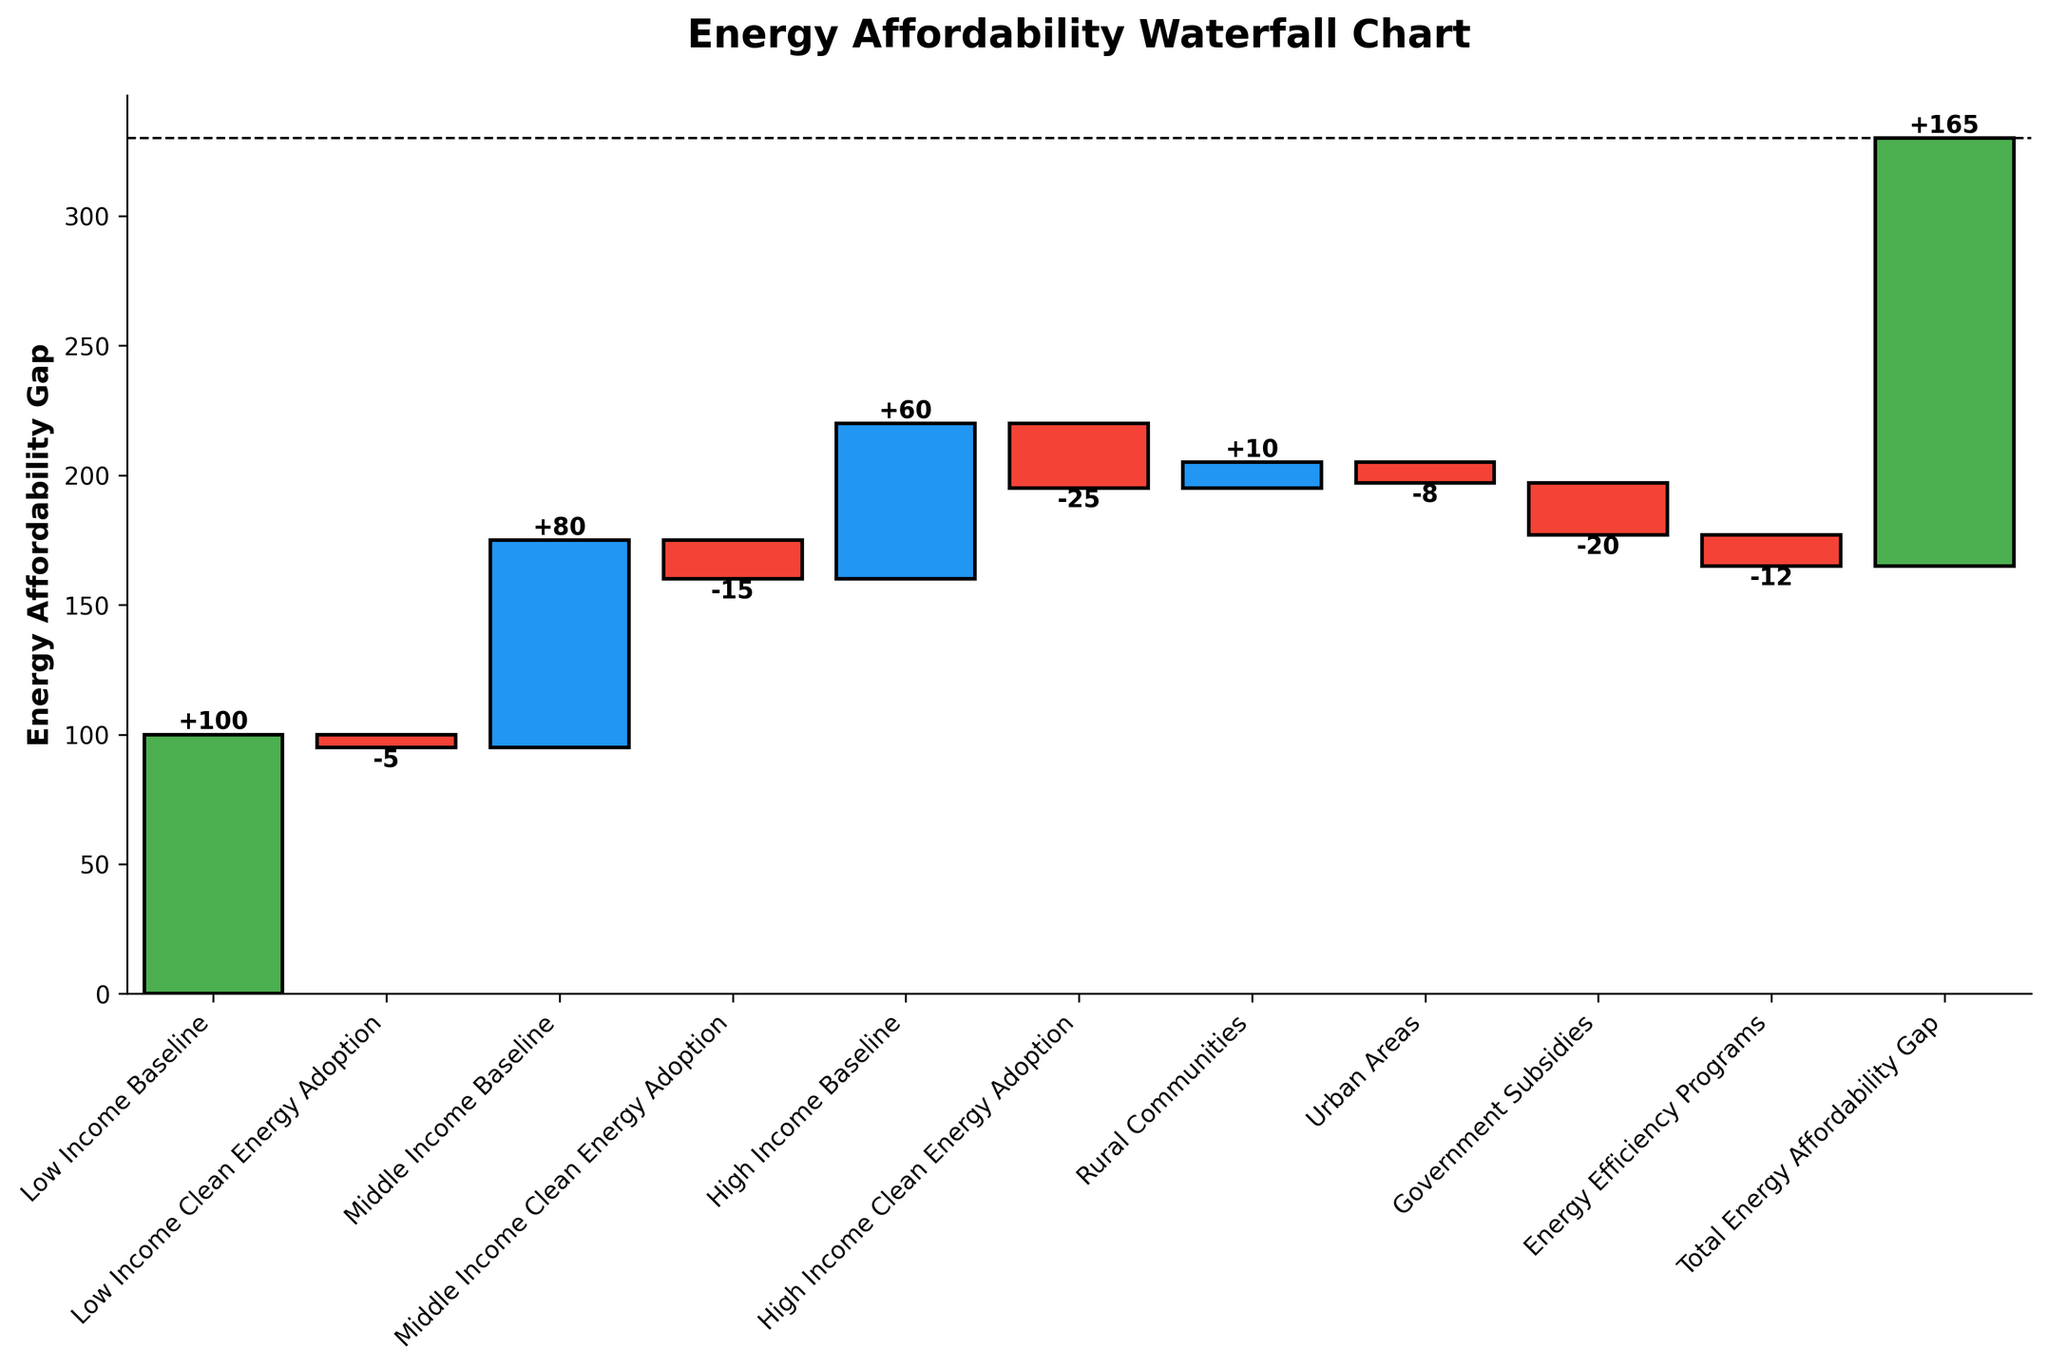What is the total energy affordability gap? The total energy affordability gap is shown at the end of the chart in the final bar labeled "Total Energy Affordability Gap". The cumulative sum for this bar indicates the total gap.
Answer: 165 Which income group has the highest clean energy adoption rate? Comparing the values labeled under "Clean Energy Adoption" for Low, Middle, and High Income groups, the High Income group has the largest negative value indicating the highest reduction in the energy affordability gap due to clean energy adoption.
Answer: High Income How does energy efficiency programs' impact compare to government subsidies? The values for "Government Subsidies" and "Energy Efficiency Programs" show -20 and -12, respectively. Subtract the value for energy efficiency programs from government subsidies to understand the difference.
Answer: Government Subsidies have a higher impact (-20 vs. -12) What is the combined impact of clean energy adoption across all income groups? Sum the clean energy adoption values for Low (-5), Middle (-15), and High Income (-25) to get the combined impact.
Answer: -45 Which group results in an increase in the affordability gap, and by how much? Identify the categories with positive values. The "Rural Communities" category shows a positive value of 10.
Answer: Rural Communities, 10 What is the lowest value observed in the chart and which category does it belong to? The chart shows values like -25, -20, -15, etc., with the lowest value being -25 under "High Income Clean Energy Adoption".
Answer: -25, High Income Clean Energy Adoption What is the total reduction in the energy affordability gap due to urban and rural area factors? Add the values of "Rural Communities" and "Urban Areas" (10 and -8).
Answer: 2 Which group's baseline has the highest energy affordability burden? Compare the baseline values for Low, Middle, and High Income groups. The "Low Income Baseline" is the highest with a value of 100.
Answer: Low Income Baseline What is the net impact of government subsidies and energy efficiency programs on the affordability gap? Sum the values of "Government Subsidies" and "Energy Efficiency Programs" (-20 and -12) to get the net impact.
Answer: -32 